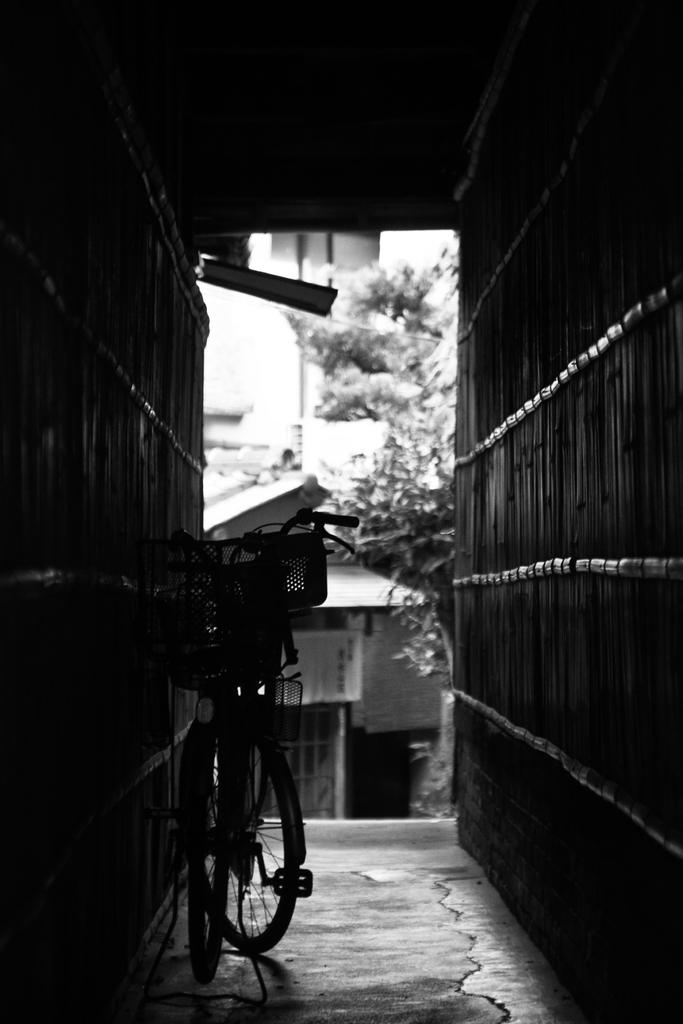What is the main object in the picture? There is a bicycle in the picture. What else can be seen in the picture besides the bicycle? There are houses and trees in the picture. Where is the goat located in the picture? There is no goat present in the picture. What type of plastic material can be seen in the picture? There is no plastic material visible in the picture. 